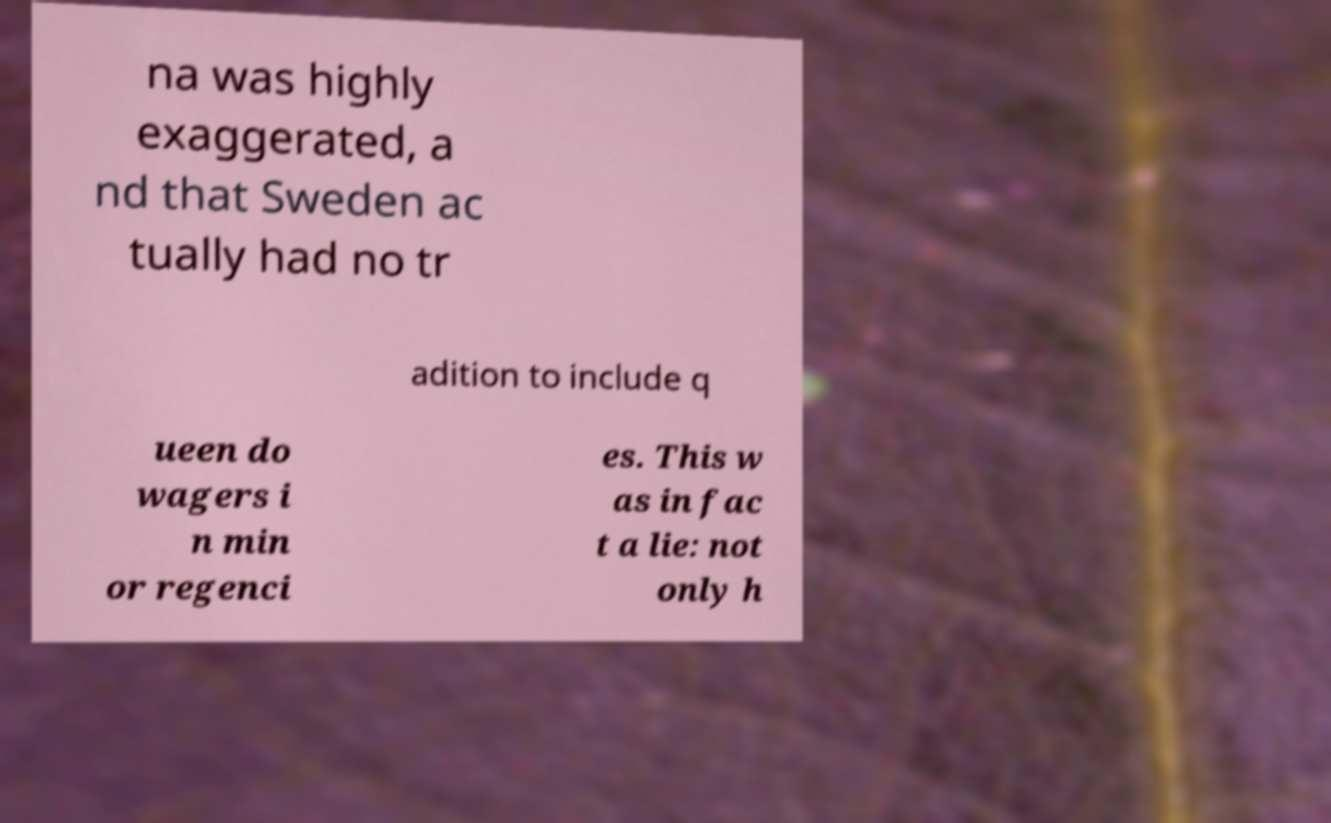Please read and relay the text visible in this image. What does it say? na was highly exaggerated, a nd that Sweden ac tually had no tr adition to include q ueen do wagers i n min or regenci es. This w as in fac t a lie: not only h 